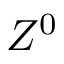<formula> <loc_0><loc_0><loc_500><loc_500>Z ^ { 0 }</formula> 